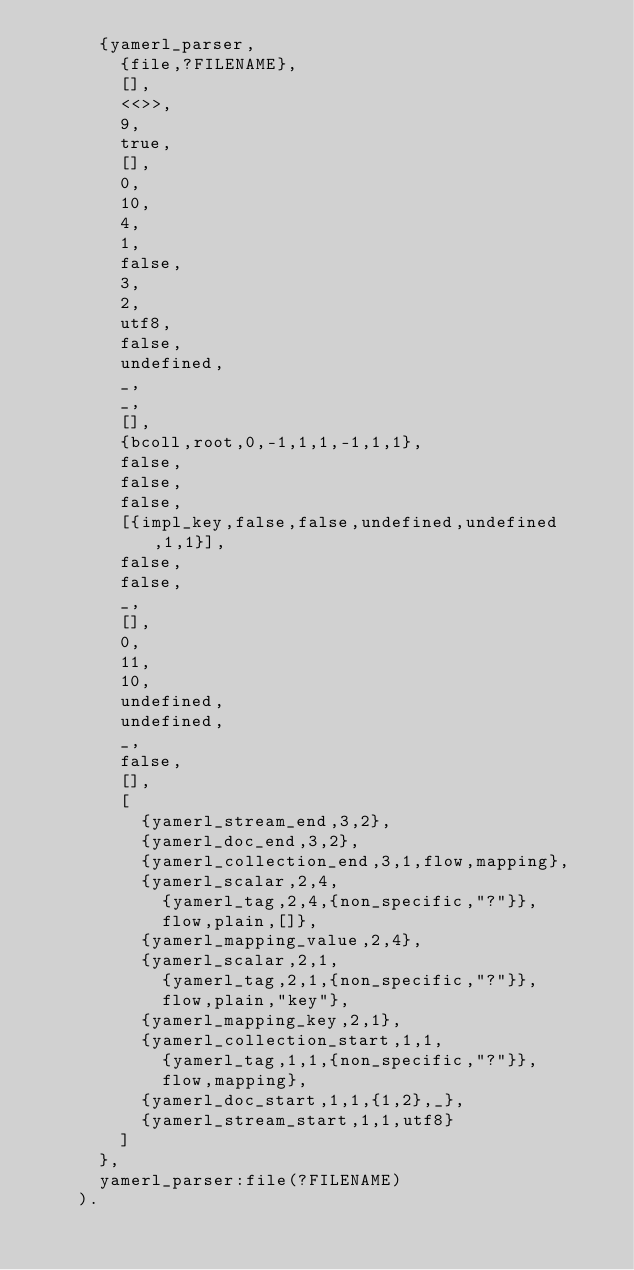Convert code to text. <code><loc_0><loc_0><loc_500><loc_500><_Erlang_>      {yamerl_parser,
        {file,?FILENAME},
        [],
        <<>>,
        9,
        true,
        [],
        0,
        10,
        4,
        1,
        false,
        3,
        2,
        utf8,
        false,
        undefined,
        _,
        _,
        [],
        {bcoll,root,0,-1,1,1,-1,1,1},
        false,
        false,
        false,
        [{impl_key,false,false,undefined,undefined,1,1}],
        false,
        false,
        _,
        [],
        0,
        11,
        10,
        undefined,
        undefined,
        _,
        false,
        [],
        [
          {yamerl_stream_end,3,2},
          {yamerl_doc_end,3,2},
          {yamerl_collection_end,3,1,flow,mapping},
          {yamerl_scalar,2,4,
            {yamerl_tag,2,4,{non_specific,"?"}},
            flow,plain,[]},
          {yamerl_mapping_value,2,4},
          {yamerl_scalar,2,1,
            {yamerl_tag,2,1,{non_specific,"?"}},
            flow,plain,"key"},
          {yamerl_mapping_key,2,1},
          {yamerl_collection_start,1,1,
            {yamerl_tag,1,1,{non_specific,"?"}},
            flow,mapping},
          {yamerl_doc_start,1,1,{1,2},_},
          {yamerl_stream_start,1,1,utf8}
        ]
      },
      yamerl_parser:file(?FILENAME)
    ).
</code> 